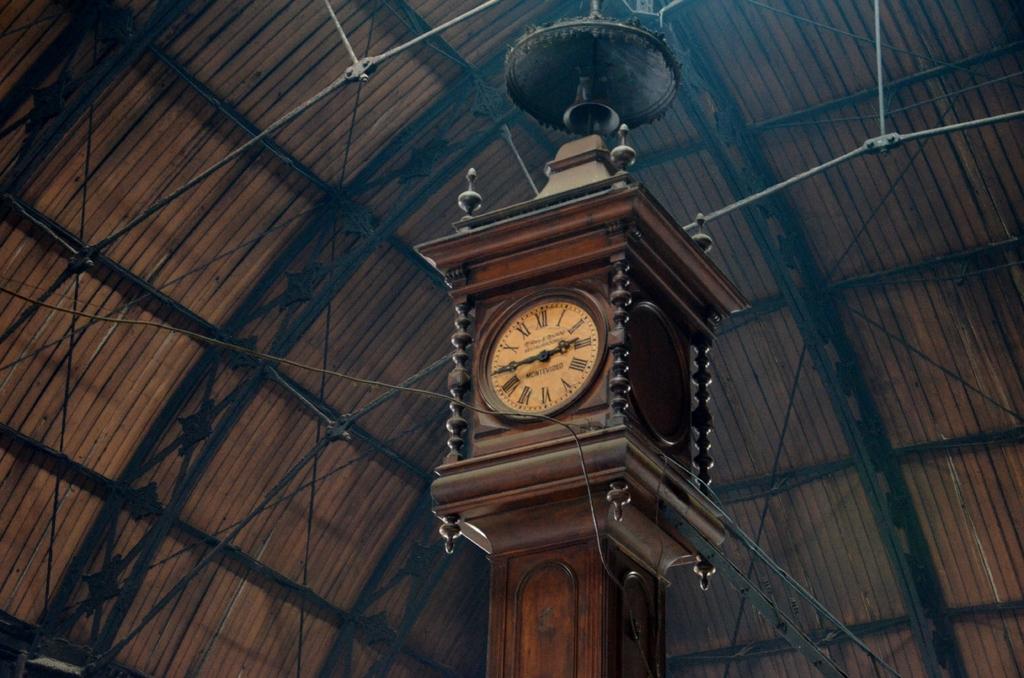What does the very top roman numeral say?
Keep it short and to the point. Xii. 